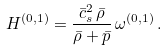<formula> <loc_0><loc_0><loc_500><loc_500>H ^ { ( 0 , 1 ) } = \frac { \bar { c } _ { s } ^ { 2 } \, \bar { \rho } } { \bar { \rho } + \bar { p } } \, \omega ^ { ( 0 , 1 ) } \, .</formula> 